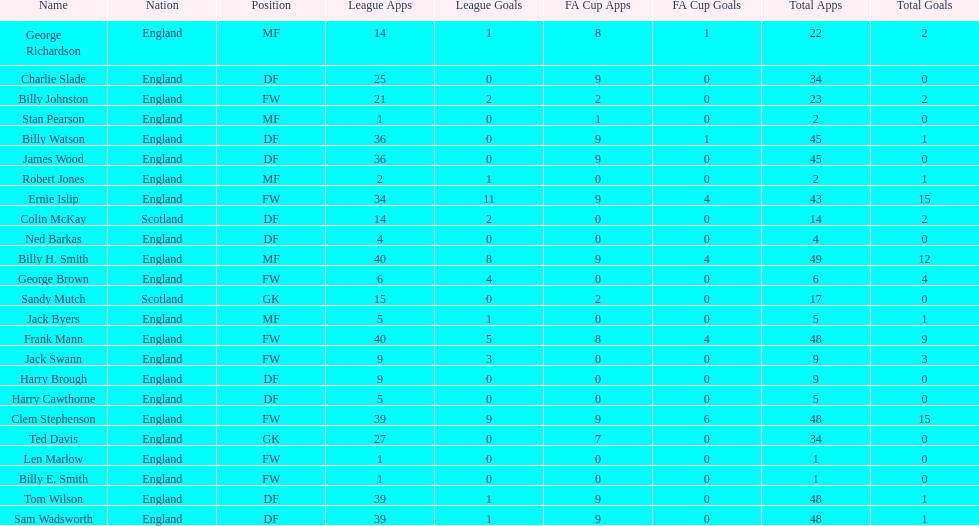What is the last name listed on this chart? James Wood. 